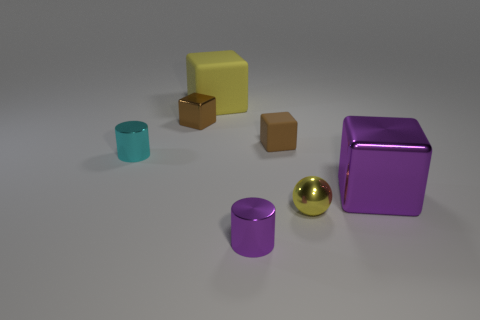There is a small metallic thing behind the small shiny cylinder that is left of the big block that is on the left side of the purple cylinder; what is its color?
Give a very brief answer. Brown. Are there an equal number of large purple metal things behind the cyan metal object and brown rubber things?
Keep it short and to the point. No. There is a metallic cylinder that is in front of the cyan cylinder; is its size the same as the cyan object?
Your answer should be compact. Yes. How many spheres are there?
Your answer should be very brief. 1. How many shiny objects are in front of the tiny brown matte object and left of the big purple metal cube?
Provide a short and direct response. 3. Is there a cyan sphere that has the same material as the tiny yellow object?
Keep it short and to the point. No. What material is the big object that is on the left side of the small brown thing to the right of the yellow rubber block?
Give a very brief answer. Rubber. Is the number of cyan metal cylinders to the left of the cyan metal cylinder the same as the number of objects in front of the tiny yellow metal thing?
Give a very brief answer. No. Does the tiny purple object have the same shape as the cyan thing?
Keep it short and to the point. Yes. The block that is both left of the tiny purple metal cylinder and in front of the yellow matte cube is made of what material?
Give a very brief answer. Metal. 